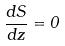Convert formula to latex. <formula><loc_0><loc_0><loc_500><loc_500>\frac { d S } { d z } = 0</formula> 